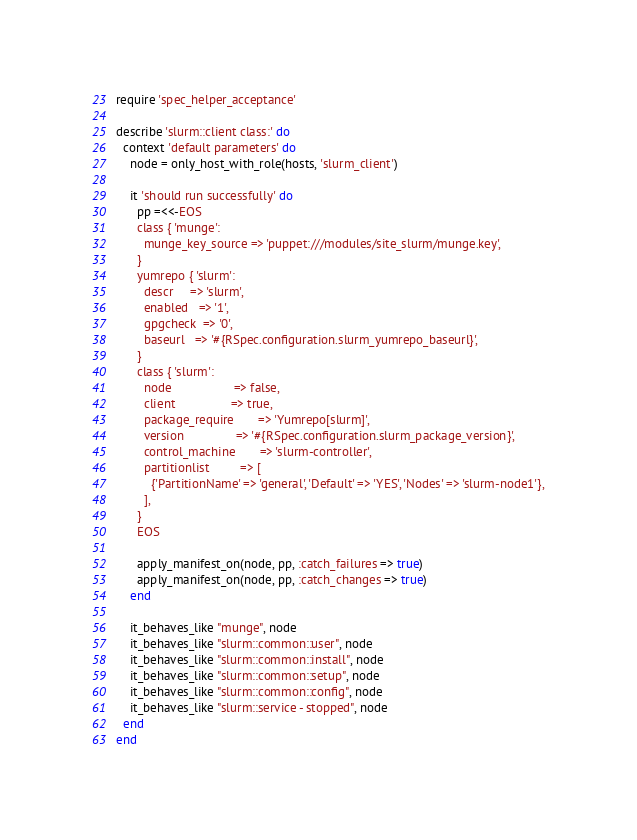Convert code to text. <code><loc_0><loc_0><loc_500><loc_500><_Ruby_>require 'spec_helper_acceptance'

describe 'slurm::client class:' do
  context 'default parameters' do
    node = only_host_with_role(hosts, 'slurm_client')

    it 'should run successfully' do
      pp =<<-EOS
      class { 'munge':
        munge_key_source => 'puppet:///modules/site_slurm/munge.key',
      }
      yumrepo { 'slurm':
        descr     => 'slurm',
        enabled   => '1',
        gpgcheck  => '0',
        baseurl   => '#{RSpec.configuration.slurm_yumrepo_baseurl}',
      }
      class { 'slurm':
        node                  => false,
        client                => true,
        package_require       => 'Yumrepo[slurm]',
        version               => '#{RSpec.configuration.slurm_package_version}',
        control_machine       => 'slurm-controller',
        partitionlist         => [
          {'PartitionName' => 'general', 'Default' => 'YES', 'Nodes' => 'slurm-node1'},
        ],
      }
      EOS

      apply_manifest_on(node, pp, :catch_failures => true)
      apply_manifest_on(node, pp, :catch_changes => true)
    end

    it_behaves_like "munge", node
    it_behaves_like "slurm::common::user", node
    it_behaves_like "slurm::common::install", node
    it_behaves_like "slurm::common::setup", node
    it_behaves_like "slurm::common::config", node
    it_behaves_like "slurm::service - stopped", node
  end
end</code> 